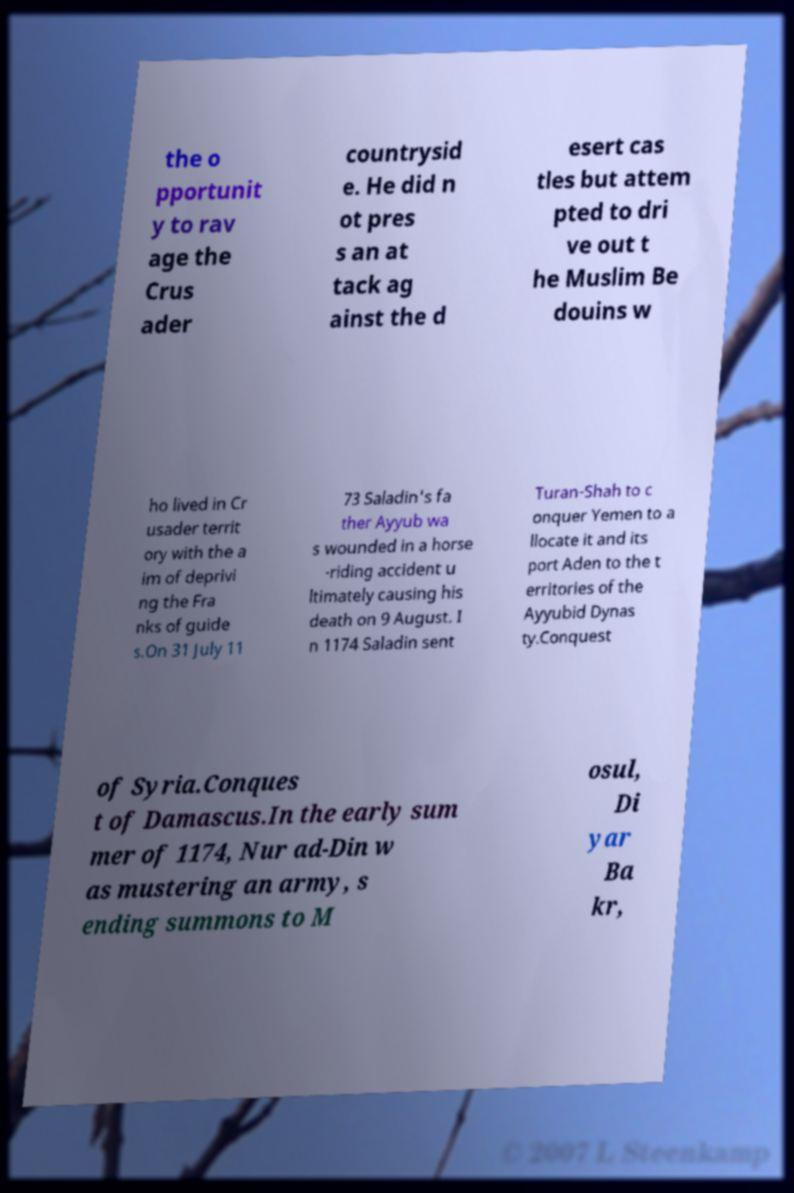Could you extract and type out the text from this image? the o pportunit y to rav age the Crus ader countrysid e. He did n ot pres s an at tack ag ainst the d esert cas tles but attem pted to dri ve out t he Muslim Be douins w ho lived in Cr usader territ ory with the a im of deprivi ng the Fra nks of guide s.On 31 July 11 73 Saladin's fa ther Ayyub wa s wounded in a horse -riding accident u ltimately causing his death on 9 August. I n 1174 Saladin sent Turan-Shah to c onquer Yemen to a llocate it and its port Aden to the t erritories of the Ayyubid Dynas ty.Conquest of Syria.Conques t of Damascus.In the early sum mer of 1174, Nur ad-Din w as mustering an army, s ending summons to M osul, Di yar Ba kr, 